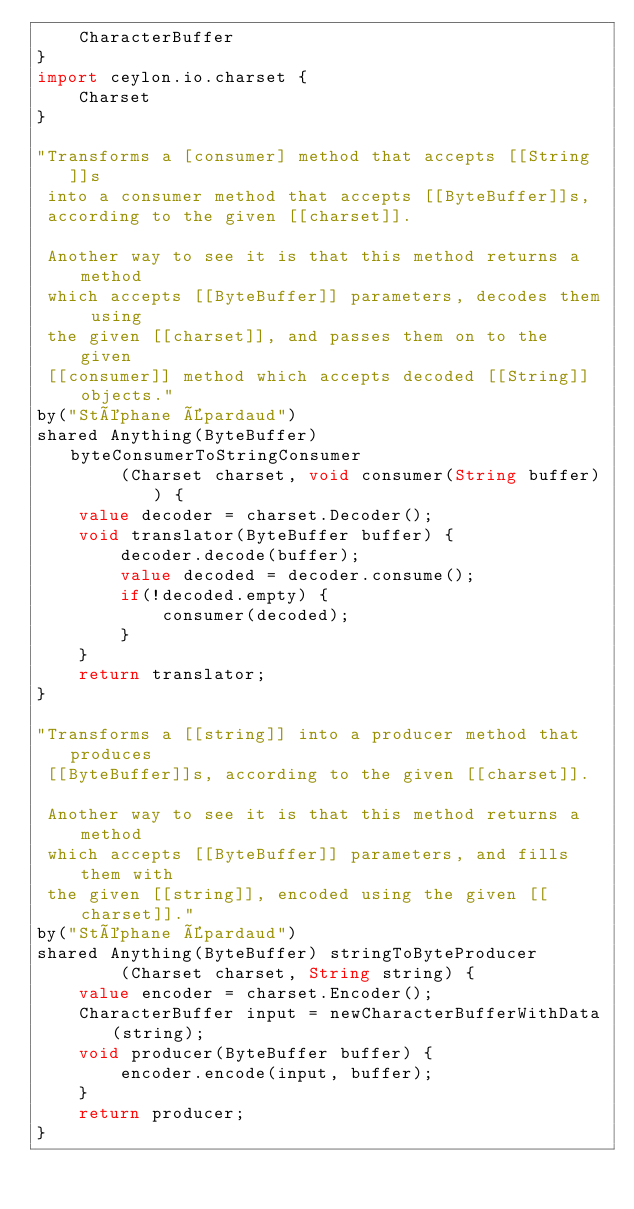Convert code to text. <code><loc_0><loc_0><loc_500><loc_500><_Ceylon_>    CharacterBuffer
}
import ceylon.io.charset {
    Charset
}

"Transforms a [consumer] method that accepts [[String]]s 
 into a consumer method that accepts [[ByteBuffer]]s, 
 according to the given [[charset]].
 
 Another way to see it is that this method returns a method 
 which accepts [[ByteBuffer]] parameters, decodes them using 
 the given [[charset]], and passes them on to the given 
 [[consumer]] method which accepts decoded [[String]] objects."
by("Stéphane Épardaud")
shared Anything(ByteBuffer) byteConsumerToStringConsumer
        (Charset charset, void consumer(String buffer)) {
    value decoder = charset.Decoder();
    void translator(ByteBuffer buffer) {
        decoder.decode(buffer);
        value decoded = decoder.consume();
        if(!decoded.empty) {
            consumer(decoded);
        }
    }
    return translator;
}

"Transforms a [[string]] into a producer method that produces 
 [[ByteBuffer]]s, according to the given [[charset]].
 
 Another way to see it is that this method returns a method 
 which accepts [[ByteBuffer]] parameters, and fills them with 
 the given [[string]], encoded using the given [[charset]]."
by("Stéphane Épardaud")
shared Anything(ByteBuffer) stringToByteProducer
        (Charset charset, String string) {
    value encoder = charset.Encoder();
    CharacterBuffer input = newCharacterBufferWithData(string);
    void producer(ByteBuffer buffer) {
        encoder.encode(input, buffer);
    }
    return producer;
}
</code> 